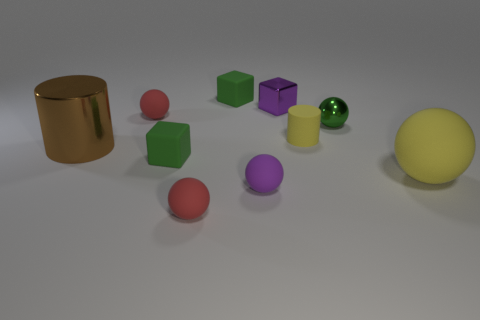Is the color of the small rubber cylinder that is to the right of the tiny purple rubber thing the same as the large matte ball?
Provide a succinct answer. Yes. Is the number of large metal things less than the number of cyan balls?
Provide a short and direct response. No. What shape is the red rubber thing that is behind the brown metal cylinder left of the red matte thing in front of the small purple matte object?
Provide a short and direct response. Sphere. How many objects are either tiny red matte balls behind the tiny yellow rubber thing or green things that are left of the purple rubber ball?
Provide a short and direct response. 3. There is a brown shiny cylinder; are there any metal things left of it?
Provide a short and direct response. No. What number of things are either tiny matte objects in front of the yellow sphere or yellow cylinders?
Offer a terse response. 3. How many green objects are either matte spheres or small rubber cubes?
Your answer should be compact. 2. How many other things are the same color as the shiny cylinder?
Give a very brief answer. 0. Is the number of red objects behind the big rubber thing less than the number of big shiny objects?
Offer a terse response. No. There is a tiny cube left of the red matte thing that is in front of the large matte object that is in front of the brown cylinder; what is its color?
Your response must be concise. Green. 